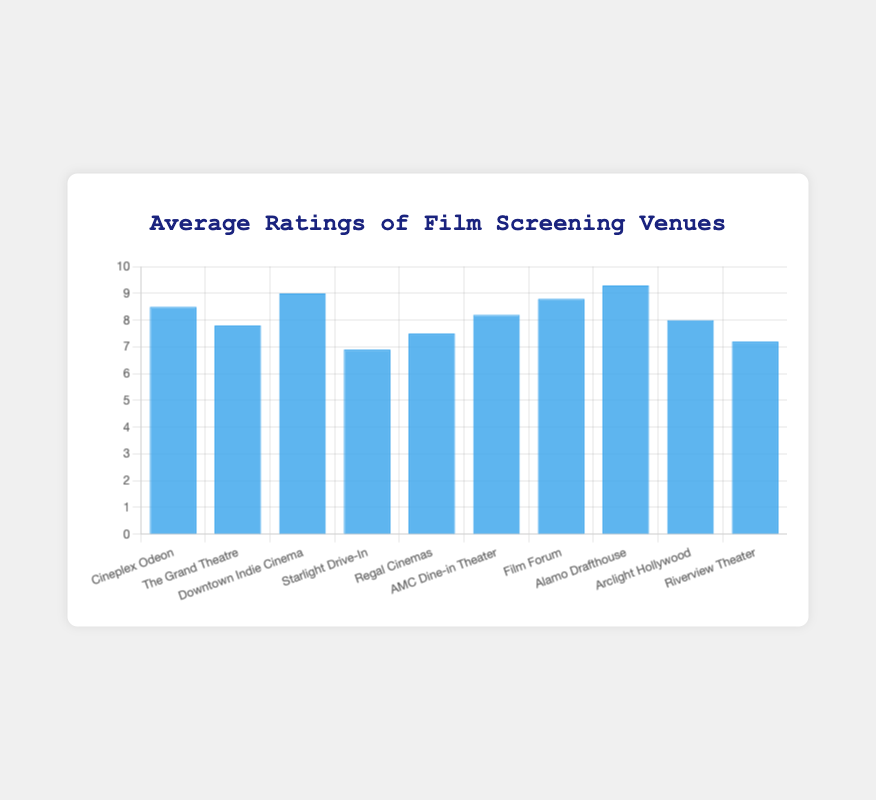What is the average rating of Downton Indie Cinema? The bar corresponding to "Downtown Indie Cinema" has an average rating of 9.0.
Answer: 9.0 Which venue has the highest average rating? The bar for "Alamo Drafthouse" is the tallest, indicating it has the highest average rating of 9.3.
Answer: Alamo Drafthouse What is the difference in average rating between Cineplex Odeon and The Grand Theatre? Cineplex Odeon's rating is 8.5, and The Grand Theatre's rating is 7.8. Subtracting these gives 8.5 - 7.8 = 0.7.
Answer: 0.7 Which venue has the lowest average rating? The shortest bar corresponds to "Starlight Drive-In" with an average rating of 6.9.
Answer: Starlight Drive-In How many venues have an average rating of 8.0 or higher? Cineplex Odeon (8.5), Downtown Indie Cinema (9.0), AMC Dine-in Theater (8.2), Film Forum (8.8), Alamo Drafthouse (9.3), and Arclight Hollywood (8.0) all have ratings of 8.0 or higher. There are 6 such venues.
Answer: 6 Which venue has a higher average rating: AMC Dine-in Theater or Regal Cinemas? AMC Dine-in Theater has a rating of 8.2, while Regal Cinemas has a rating of 7.5; thus, AMC Dine-in Theater has a higher rating.
Answer: AMC Dine-in Theater What is the sum of the average ratings for Film Forum and Riverview Theater? Film Forum's rating is 8.8 and Riverview Theater's rating is 7.2. Adding these gives 8.8 + 7.2 = 16.0.
Answer: 16.0 Are there any venues with equal average ratings? None of the bars have the same height, indicating there are no equal average ratings.
Answer: No What is the median average rating of all the venues? To find the median, list all ratings in ascending order: 6.9, 7.2, 7.5, 7.8, 8.0, 8.2, 8.5, 8.8, 9.0, 9.3. The middle values are 8.0 and 8.2. The median is (8.0 + 8.2) / 2 = 8.1.
Answer: 8.1 How much more is the average rating of Alamo Drafthouse compared to Starlight Drive-In? Alamo Drafthouse's rating is 9.3 and Starlight Drive-In's rating is 6.9. The difference is 9.3 - 6.9 = 2.4.
Answer: 2.4 